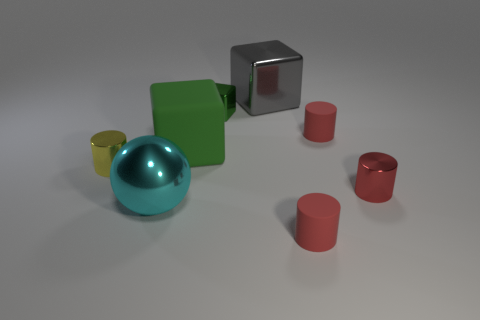There is another metal object that is the same shape as the big gray thing; what is its color?
Give a very brief answer. Green. Is there anything else of the same color as the matte cube?
Your answer should be compact. Yes. Is the number of small cylinders greater than the number of tiny red cubes?
Your answer should be very brief. Yes. Does the cyan sphere have the same material as the large gray block?
Ensure brevity in your answer.  Yes. How many yellow cylinders are the same material as the big cyan sphere?
Keep it short and to the point. 1. Is the size of the cyan metal thing the same as the red thing that is in front of the cyan shiny ball?
Make the answer very short. No. What color is the thing that is both to the right of the small yellow cylinder and to the left of the green rubber thing?
Give a very brief answer. Cyan. Are there any large shiny things that are to the right of the metal cube that is to the right of the small green metallic block?
Ensure brevity in your answer.  No. Are there the same number of gray metal things in front of the small green cube and green metallic objects?
Offer a terse response. No. How many large metal spheres are behind the small cylinder left of the tiny cylinder that is in front of the big cyan metal ball?
Offer a terse response. 0. 